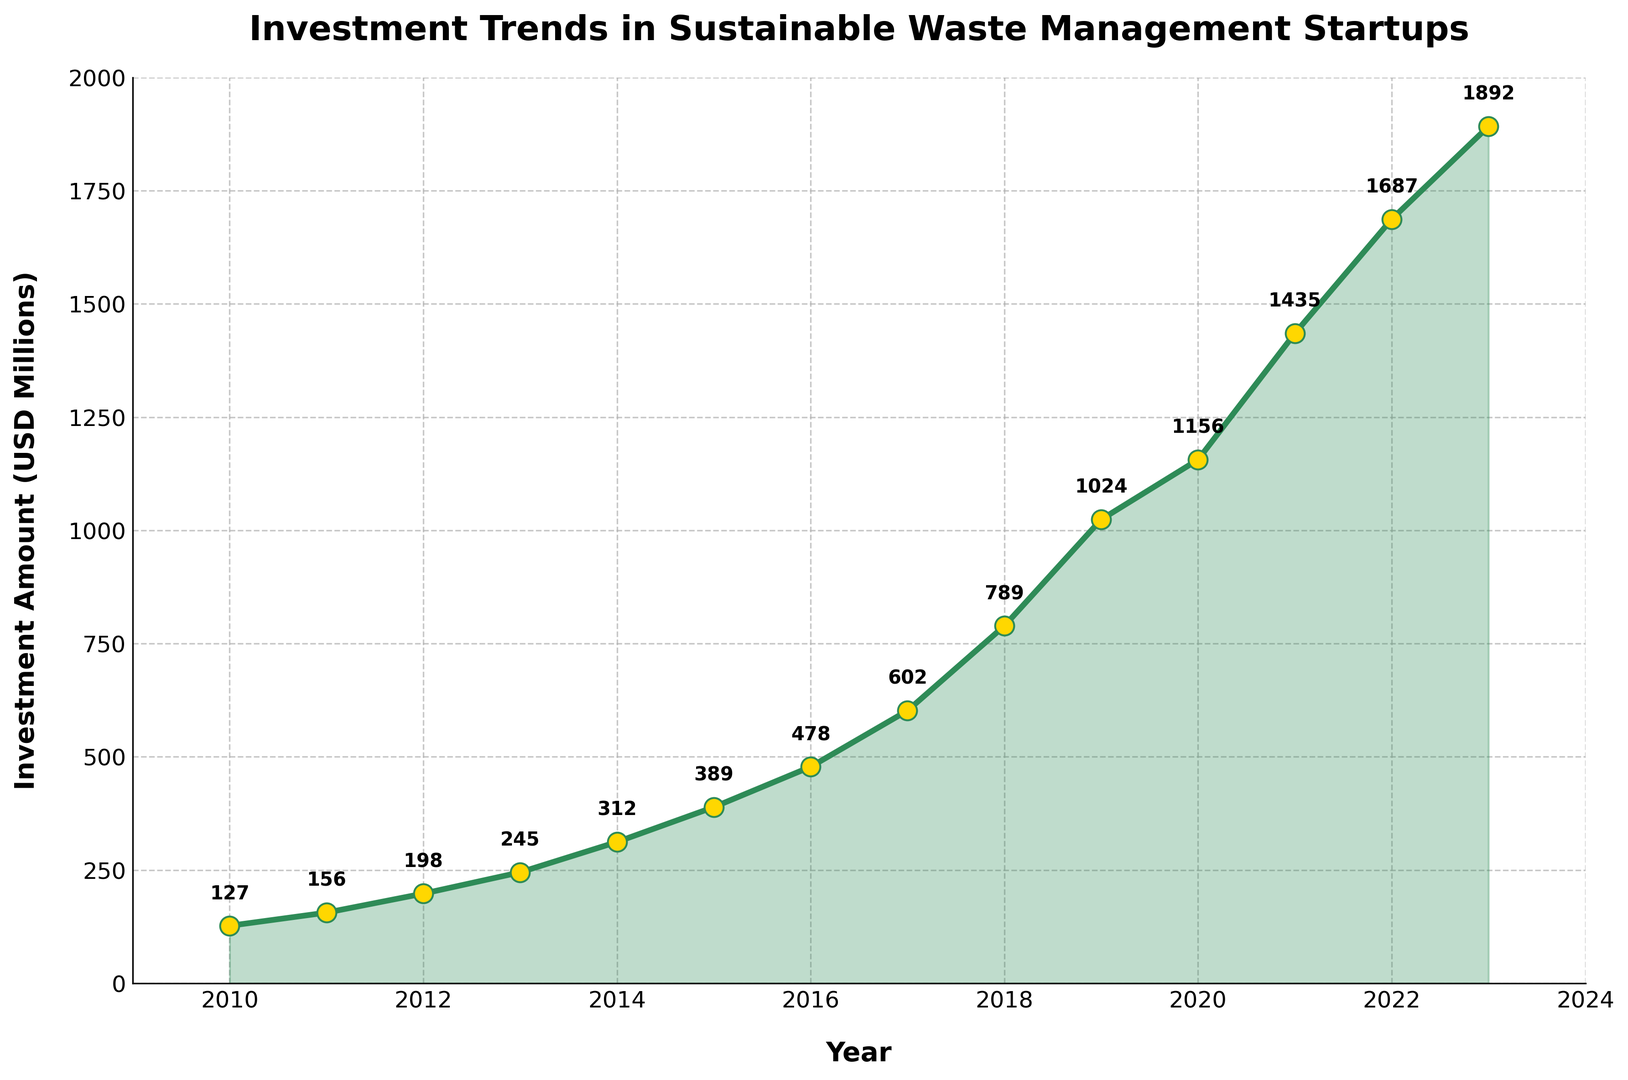What is the total investment amount in sustainable waste management startups from 2010 to 2023? Sum the investment amounts from each year: \(127 + 156 + 198 + 245 + 312 + 389 + 478 + 602 + 789 + 1024 + 1156 + 1435 + 1687 + 1892 = 12390\)
Answer: 12390 In which year did the investment amount first exceed 1000 million USD? Look at the plotted values and see which year first has a value greater than 1000: 2019 with 1024 million USD
Answer: 2019 What is the difference in investment amount between 2015 and 2023? Subtract the investment amount in 2015 from the amount in 2023: \(1892 - 389 = 1503\)
Answer: 1503 Which year saw the largest increase in investment compared to the previous year, and what was the increase? Calculate the year-to-year difference and find the maximum: The largest increase was between 2018 (789 million USD) and 2019 (1024 million USD), which is \(1024 - 789 = 235\) million USD
Answer: 2019, 235 What is the average annual investment amount from 2010 to 2023? Find the total sum and divide by the number of years: Total sum is 12390, and there are 14 years: \(12390 / 14 \approx 885\) million USD
Answer: 885 How many years did the investment amount increase compared to the previous year? Count the number of positive year-to-year differences: Every year showed an increase from 2010 to 2023 (13 increases)
Answer: 13 What is the percentage increase in investment amount from 2010 to 2023? Compute the increase and divide by the initial value, then multiply by 100: \( (1892 - 127) / 127 \times 100 \approx 1389.76\% \)
Answer: 1389.76% Between 2017 and 2022, which year had the highest investment amount? Compare the investment amounts from 2017 to 2022 and identify the highest: 2022 with 1687 million USD
Answer: 2022 Is the trend of investment amounts increasing, decreasing, or fluctuating over the period from 2010 to 2023? Observe the pattern of plotted investments; they consistently increase every year
Answer: Increasing What is the median investment amount from 2010 to 2023? Sort the investment amounts and find the middle value(s): Middle two values are for 2016 (478) and 2017 (602), so the median is \((478 + 602) / 2 = 540\) million USD
Answer: 540 